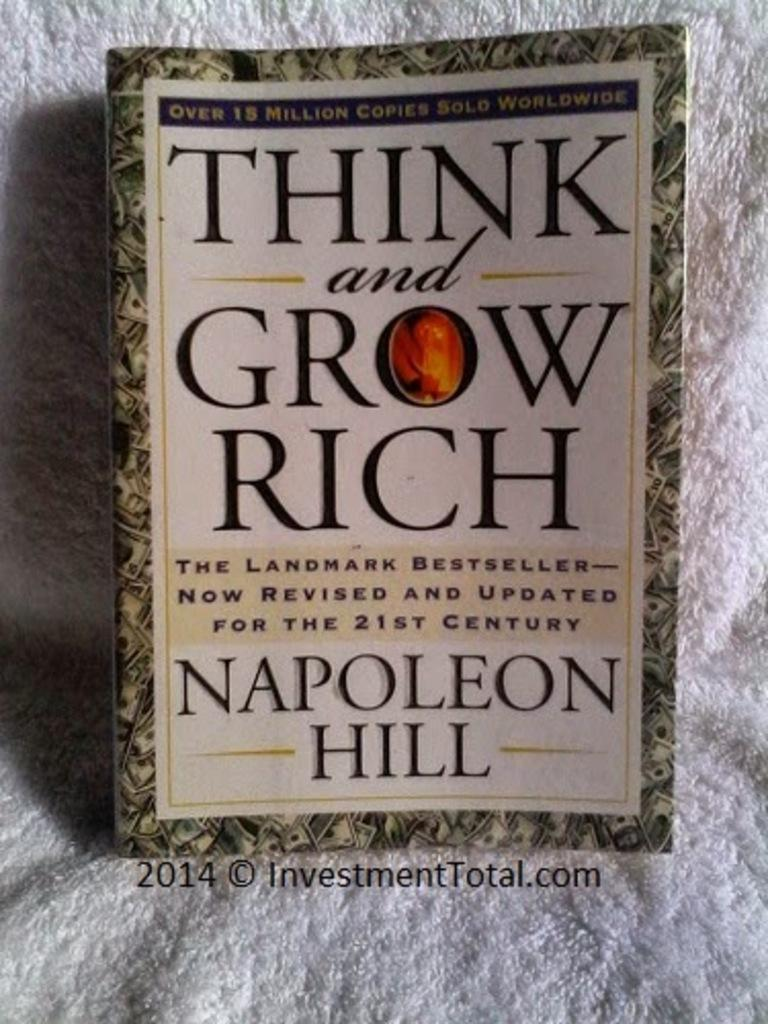<image>
Create a compact narrative representing the image presented. The book Think and Grow Rich is laying on a white towel 